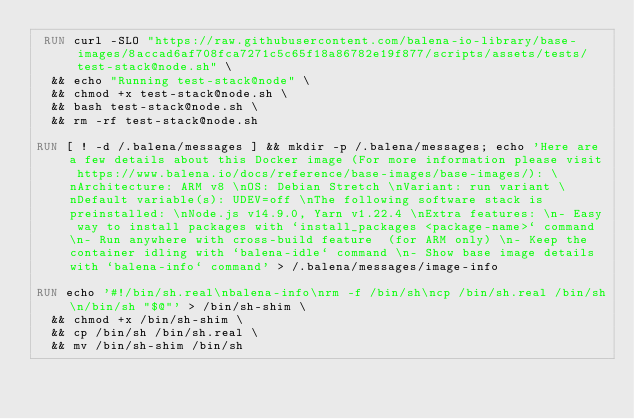<code> <loc_0><loc_0><loc_500><loc_500><_Dockerfile_> RUN curl -SLO "https://raw.githubusercontent.com/balena-io-library/base-images/8accad6af708fca7271c5c65f18a86782e19f877/scripts/assets/tests/test-stack@node.sh" \
  && echo "Running test-stack@node" \
  && chmod +x test-stack@node.sh \
  && bash test-stack@node.sh \
  && rm -rf test-stack@node.sh 

RUN [ ! -d /.balena/messages ] && mkdir -p /.balena/messages; echo 'Here are a few details about this Docker image (For more information please visit https://www.balena.io/docs/reference/base-images/base-images/): \nArchitecture: ARM v8 \nOS: Debian Stretch \nVariant: run variant \nDefault variable(s): UDEV=off \nThe following software stack is preinstalled: \nNode.js v14.9.0, Yarn v1.22.4 \nExtra features: \n- Easy way to install packages with `install_packages <package-name>` command \n- Run anywhere with cross-build feature  (for ARM only) \n- Keep the container idling with `balena-idle` command \n- Show base image details with `balena-info` command' > /.balena/messages/image-info

RUN echo '#!/bin/sh.real\nbalena-info\nrm -f /bin/sh\ncp /bin/sh.real /bin/sh\n/bin/sh "$@"' > /bin/sh-shim \
	&& chmod +x /bin/sh-shim \
	&& cp /bin/sh /bin/sh.real \
	&& mv /bin/sh-shim /bin/sh</code> 